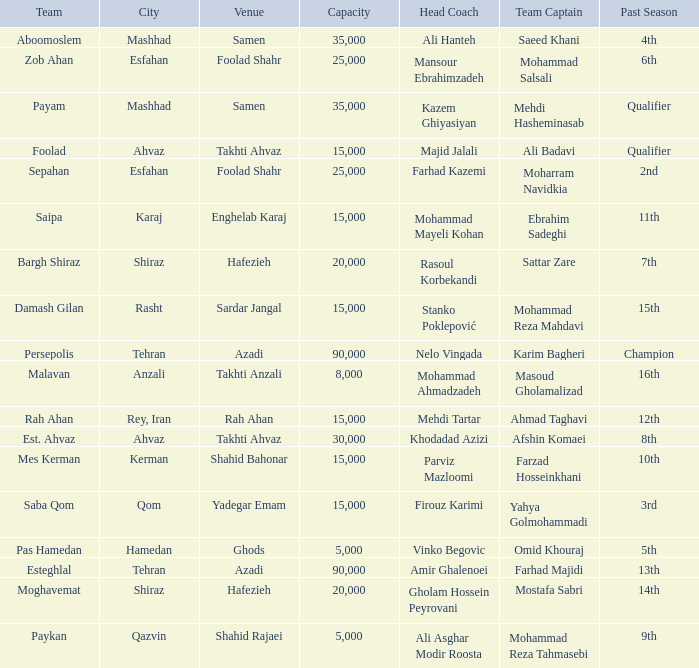What is the Capacity of the Venue of Head Coach Farhad Kazemi? 25000.0. 